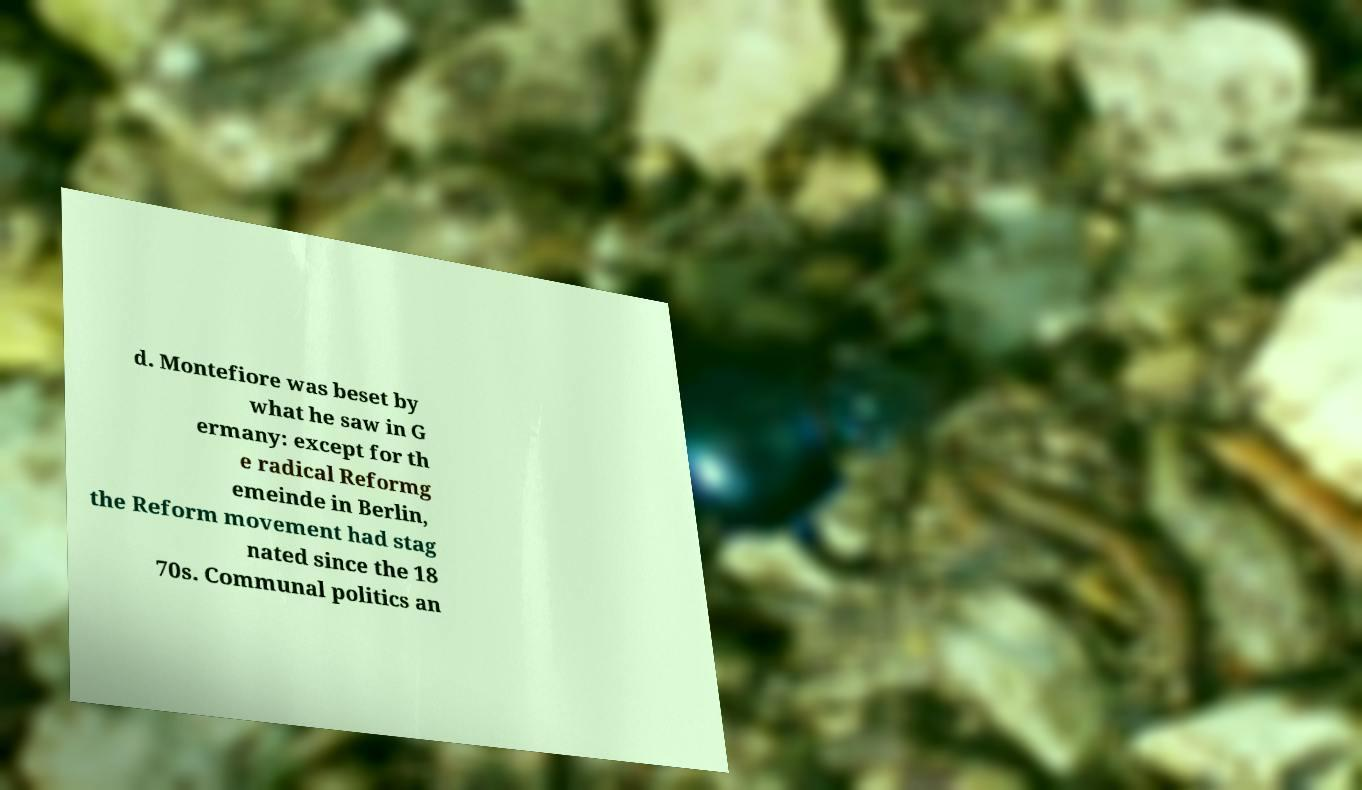There's text embedded in this image that I need extracted. Can you transcribe it verbatim? d. Montefiore was beset by what he saw in G ermany: except for th e radical Reformg emeinde in Berlin, the Reform movement had stag nated since the 18 70s. Communal politics an 